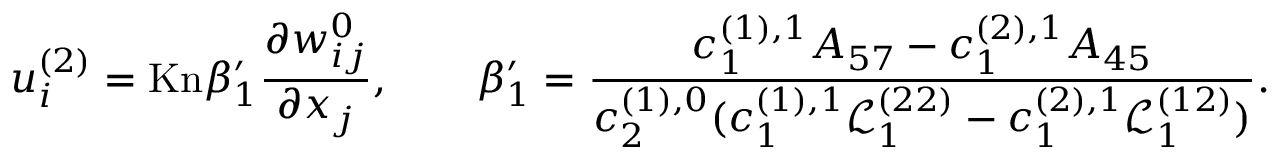Convert formula to latex. <formula><loc_0><loc_0><loc_500><loc_500>u _ { i } ^ { ( 2 ) } = K n \beta _ { 1 } ^ { \prime } \frac { \partial w _ { i j } ^ { 0 } } { \partial x _ { j } } , \quad \beta _ { 1 } ^ { \prime } = \frac { c _ { 1 } ^ { ( 1 ) , 1 } A _ { 5 7 } - c _ { 1 } ^ { ( 2 ) , 1 } A _ { 4 5 } } { c _ { 2 } ^ { ( 1 ) , 0 } ( c _ { 1 } ^ { ( 1 ) , 1 } \ m a t h s c r { L } _ { 1 } ^ { ( 2 2 ) } - c _ { 1 } ^ { ( 2 ) , 1 } \ m a t h s c r { L } _ { 1 } ^ { ( 1 2 ) } ) } .</formula> 